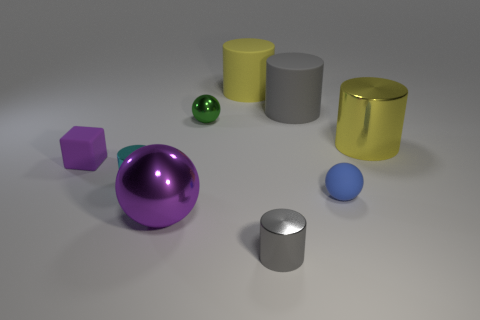Subtract 1 balls. How many balls are left? 2 Subtract all blue spheres. How many gray cylinders are left? 2 Subtract all small spheres. How many spheres are left? 1 Subtract all yellow cylinders. How many cylinders are left? 3 Subtract all red cylinders. Subtract all cyan cubes. How many cylinders are left? 5 Subtract all cylinders. How many objects are left? 4 Add 1 gray metallic cubes. How many objects exist? 10 Subtract 0 green cubes. How many objects are left? 9 Subtract all purple cylinders. Subtract all small gray metal cylinders. How many objects are left? 8 Add 1 small cyan metallic things. How many small cyan metallic things are left? 2 